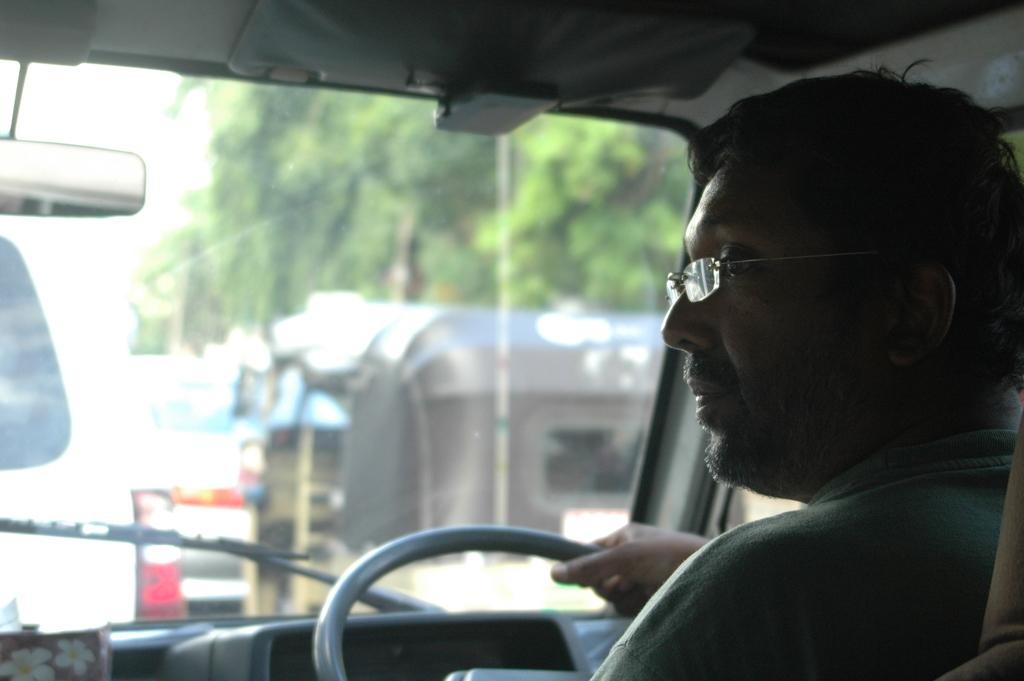What is the main subject in the middle of the image? There is a vehicle in the middle of the image. Can you describe the man's position in the image? A man is sitting on a vehicle in the bottom right side of the image. What can be seen through the window of the vehicle? Trees are visible through the window of the vehicle. How many boys are standing next to the vehicle in the image? There is no boy present in the image; only a man sitting on a vehicle is visible. 